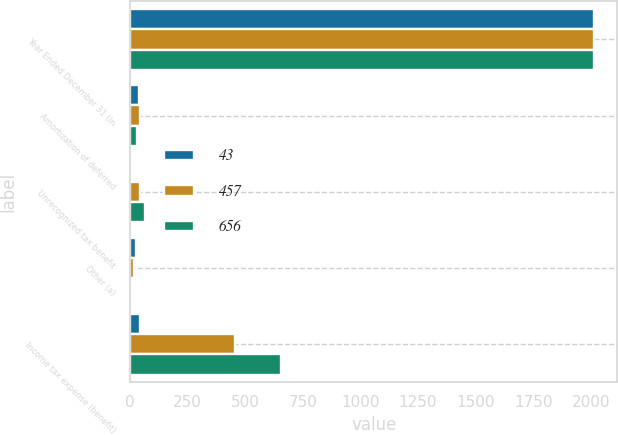Convert chart to OTSL. <chart><loc_0><loc_0><loc_500><loc_500><stacked_bar_chart><ecel><fcel>Year Ended December 31 (In<fcel>Amortization of deferred<fcel>Unrecognized tax benefit<fcel>Other (a)<fcel>Income tax expense (benefit)<nl><fcel>43<fcel>2015<fcel>38<fcel>1<fcel>24<fcel>43<nl><fcel>457<fcel>2014<fcel>44<fcel>42<fcel>16<fcel>457<nl><fcel>656<fcel>2013<fcel>31<fcel>66<fcel>3<fcel>656<nl></chart> 